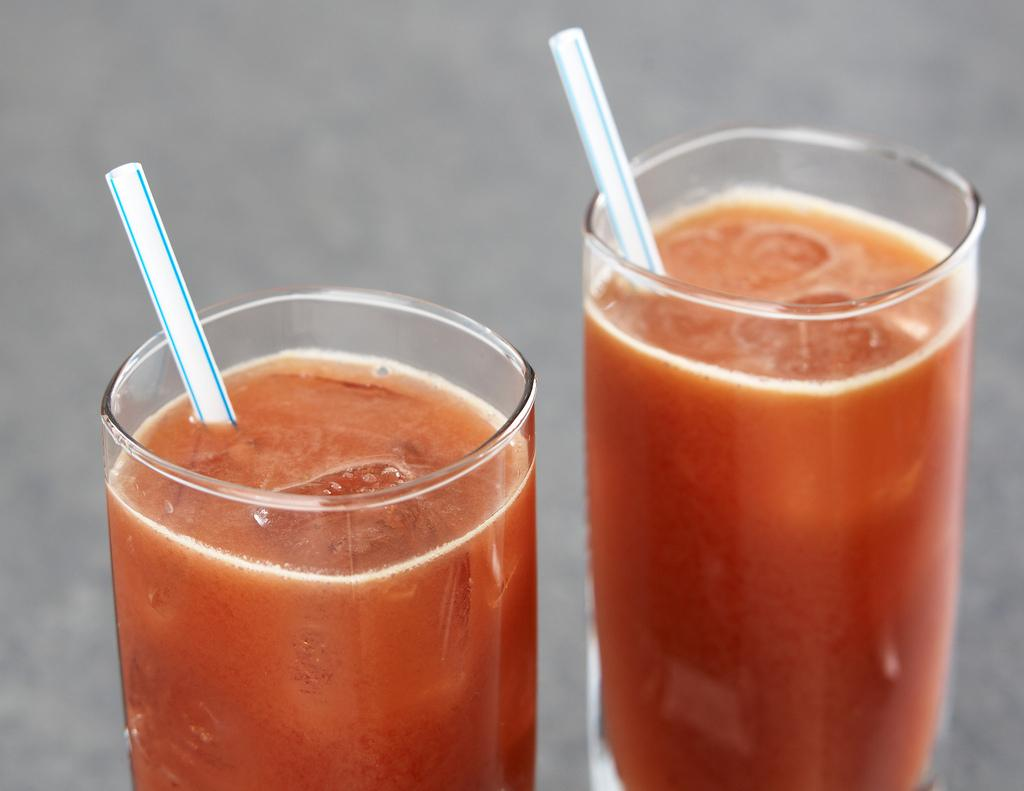How many glasses are visible in the image? There are two glasses in the image. What is inside the glasses? The glasses contain juice. What are the straws used for in the image? The straws are used for drinking the juice in the glasses. What is added to the juice to keep it cold? Ice cubes are present in the glasses to keep the juice cold. What direction is the maid facing in the image? There is no maid present in the image. Can you tell me how many chickens are in the glasses? There are no chickens present in the image; the glasses contain juice and ice cubes. 